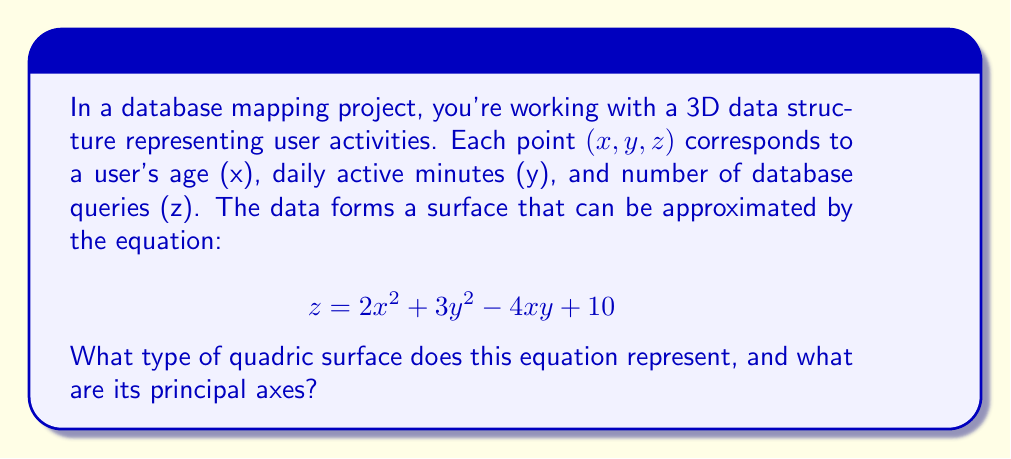What is the answer to this math problem? To determine the type of quadric surface and its principal axes, we'll follow these steps:

1) First, we need to identify the general form of a quadric surface:

   $$ Ax^2 + By^2 + Cz^2 + 2Dxy + 2Exz + 2Fyz + Gx + Hy + Iz + J = 0 $$

2) Our equation is already in the form $z = f(x,y)$, so we'll rearrange it:

   $$ 2x^2 + 3y^2 - 4xy - z + 10 = 0 $$

3) Comparing with the general form, we can identify:
   $A = 2, B = 3, C = -1, D = -2, E = F = G = H = I = 0, J = 10$

4) To determine the type of quadric surface, we need to calculate the discriminant matrix:

   $$ \begin{vmatrix} 
   A & D & E \\
   D & B & F \\
   E & F & C
   \end{vmatrix} = \begin{vmatrix}
   2 & -2 & 0 \\
   -2 & 3 & 0 \\
   0 & 0 & -1
   \end{vmatrix} $$

5) The determinant of this matrix is non-zero $(-1(2(3) - (-2)(-2)) = -1(6-4) = -2 \neq 0)$, which indicates that this is a central quadric surface.

6) Given that $C = -1 < 0$, and the other two diagonal elements $(A,B)$ are positive, this surface is an elliptic paraboloid.

7) To find the principal axes, we need to diagonalize the upper-left 2x2 submatrix:

   $$ \begin{pmatrix}
   2 & -2 \\
   -2 & 3
   \end{pmatrix} $$

8) The eigenvalues of this matrix are the roots of the characteristic equation:
   $$ (2-\lambda)(3-\lambda) - 4 = 0 $$
   $$ \lambda^2 - 5\lambda + 2 = 0 $$
   $$ \lambda = \frac{5 \pm \sqrt{25 - 8}}{2} = \frac{5 \pm \sqrt{17}}{2} $$

9) The eigenvectors corresponding to these eigenvalues will give us the directions of the principal axes in the xy-plane. The z-axis remains unchanged as the third principal axis.
Answer: Elliptic paraboloid; principal axes along eigenvectors of $\begin{pmatrix} 2 & -2 \\ -2 & 3 \end{pmatrix}$ in xy-plane and z-axis. 